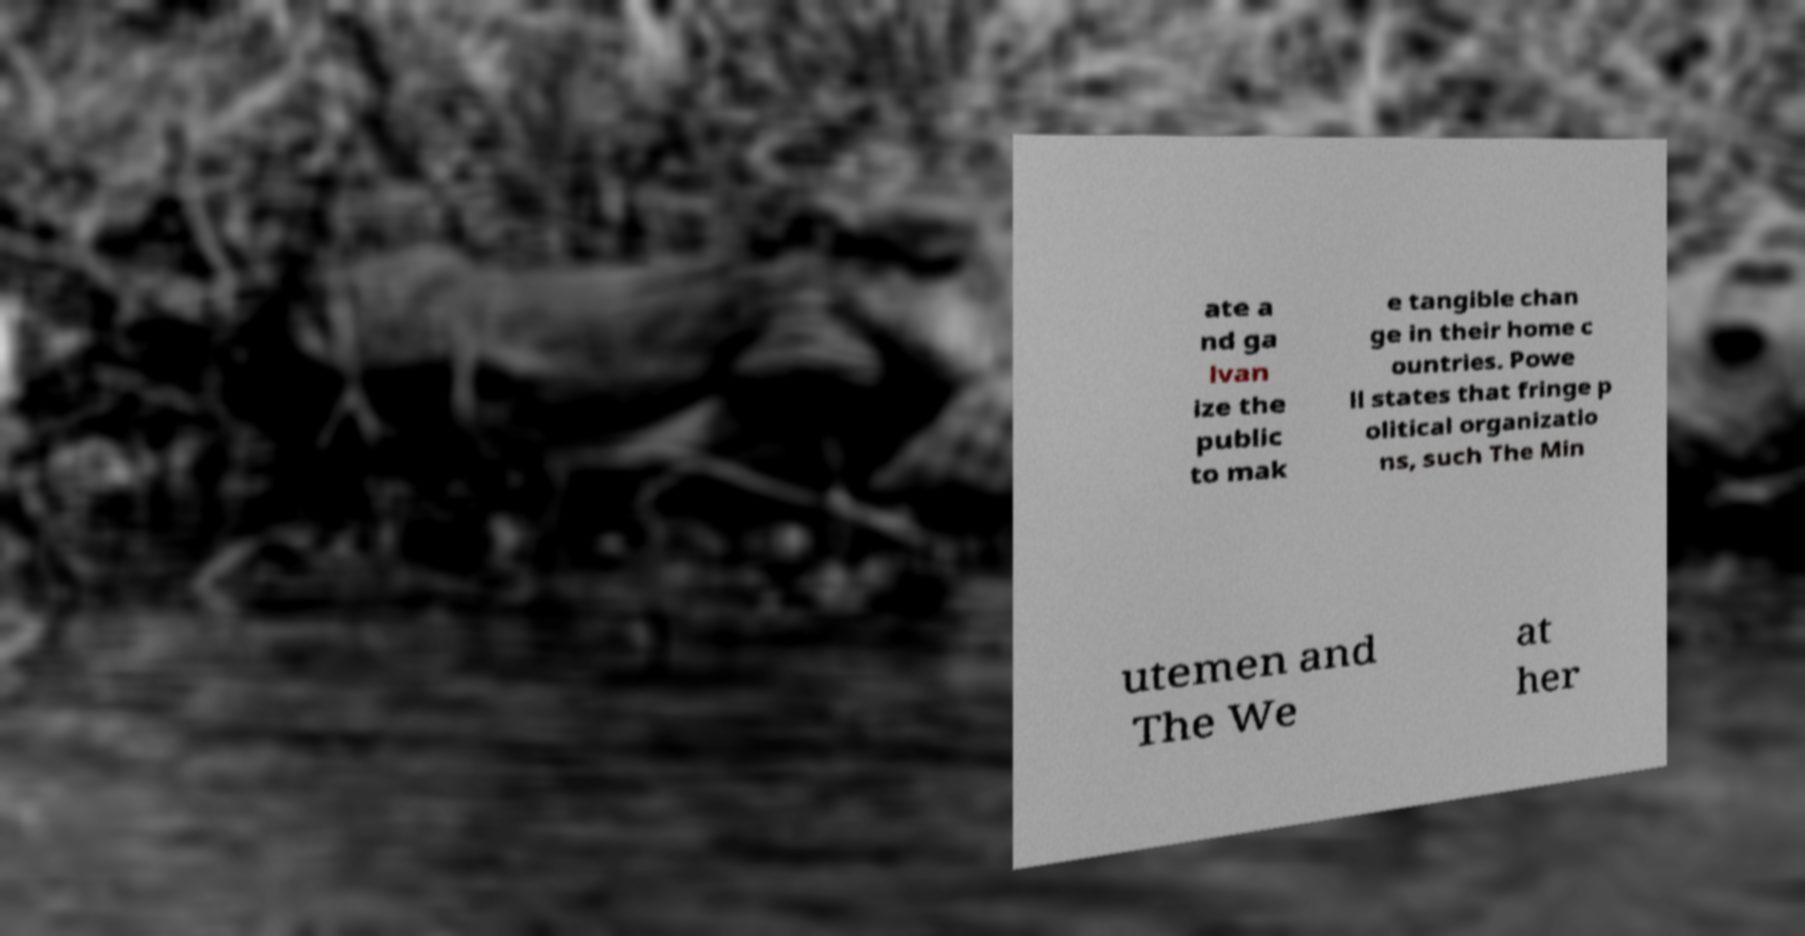Could you extract and type out the text from this image? ate a nd ga lvan ize the public to mak e tangible chan ge in their home c ountries. Powe ll states that fringe p olitical organizatio ns, such The Min utemen and The We at her 